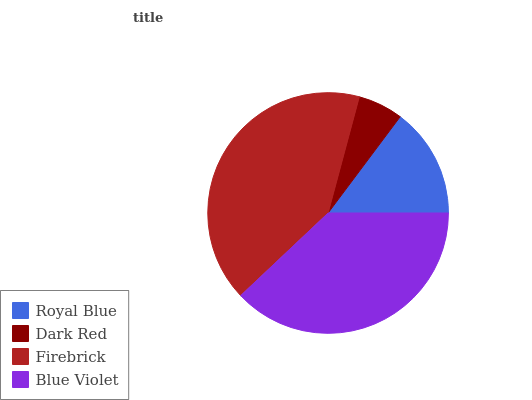Is Dark Red the minimum?
Answer yes or no. Yes. Is Firebrick the maximum?
Answer yes or no. Yes. Is Firebrick the minimum?
Answer yes or no. No. Is Dark Red the maximum?
Answer yes or no. No. Is Firebrick greater than Dark Red?
Answer yes or no. Yes. Is Dark Red less than Firebrick?
Answer yes or no. Yes. Is Dark Red greater than Firebrick?
Answer yes or no. No. Is Firebrick less than Dark Red?
Answer yes or no. No. Is Blue Violet the high median?
Answer yes or no. Yes. Is Royal Blue the low median?
Answer yes or no. Yes. Is Royal Blue the high median?
Answer yes or no. No. Is Blue Violet the low median?
Answer yes or no. No. 